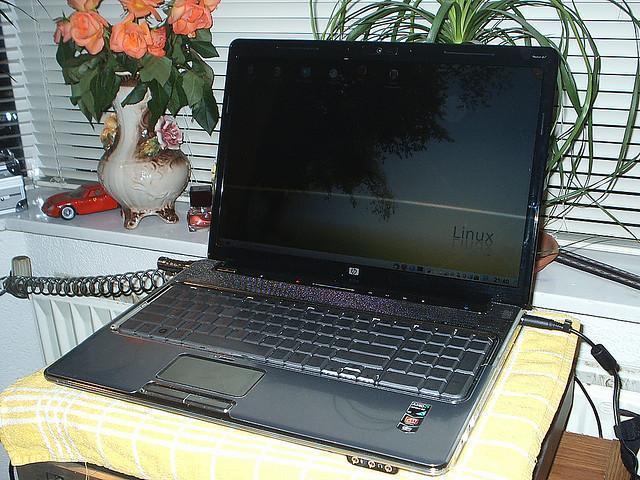How many laptops are there?
Give a very brief answer. 1. How many potted plants are there?
Give a very brief answer. 1. 